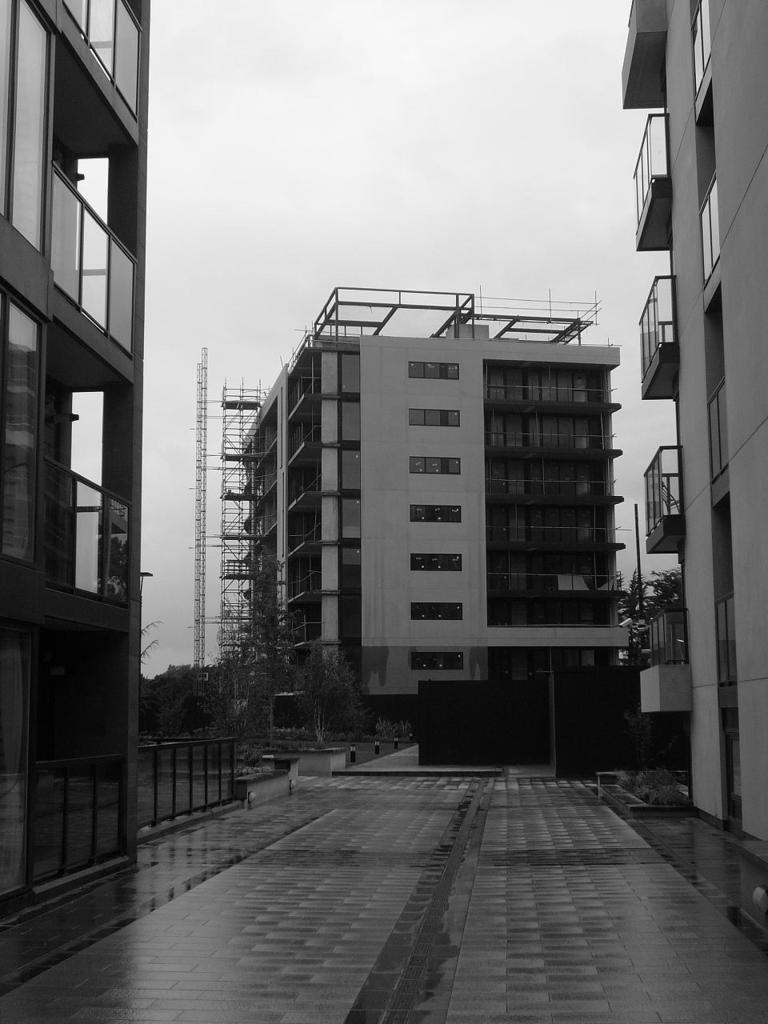Describe this image in one or two sentences. In this image there is the path. Beside the path there is a railing. In the background there are buildings and trees. At the top there is the sky. 